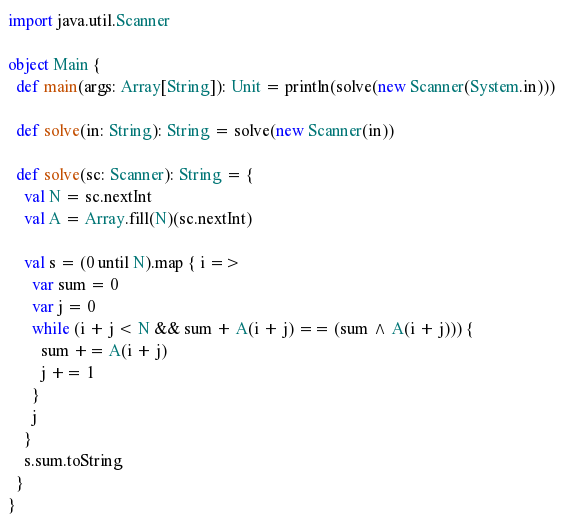<code> <loc_0><loc_0><loc_500><loc_500><_Scala_>import java.util.Scanner

object Main {
  def main(args: Array[String]): Unit = println(solve(new Scanner(System.in)))

  def solve(in: String): String = solve(new Scanner(in))

  def solve(sc: Scanner): String = {
    val N = sc.nextInt
    val A = Array.fill(N)(sc.nextInt)

    val s = (0 until N).map { i =>
      var sum = 0
      var j = 0
      while (i + j < N && sum + A(i + j) == (sum ^ A(i + j))) {
        sum += A(i + j)
        j += 1
      }
      j
    }
    s.sum.toString
  }
}
</code> 